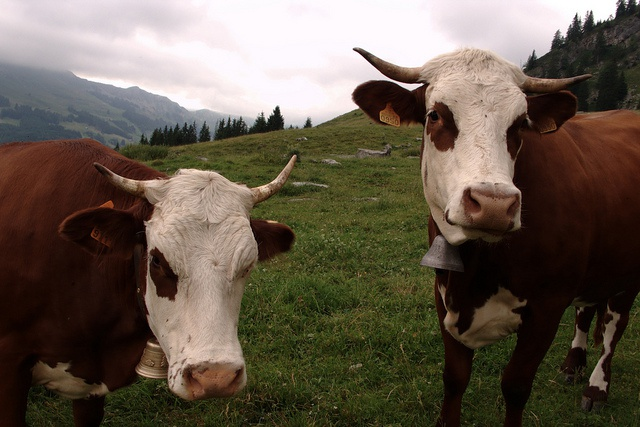Describe the objects in this image and their specific colors. I can see cow in white, black, maroon, and tan tones and cow in white, black, maroon, and tan tones in this image. 